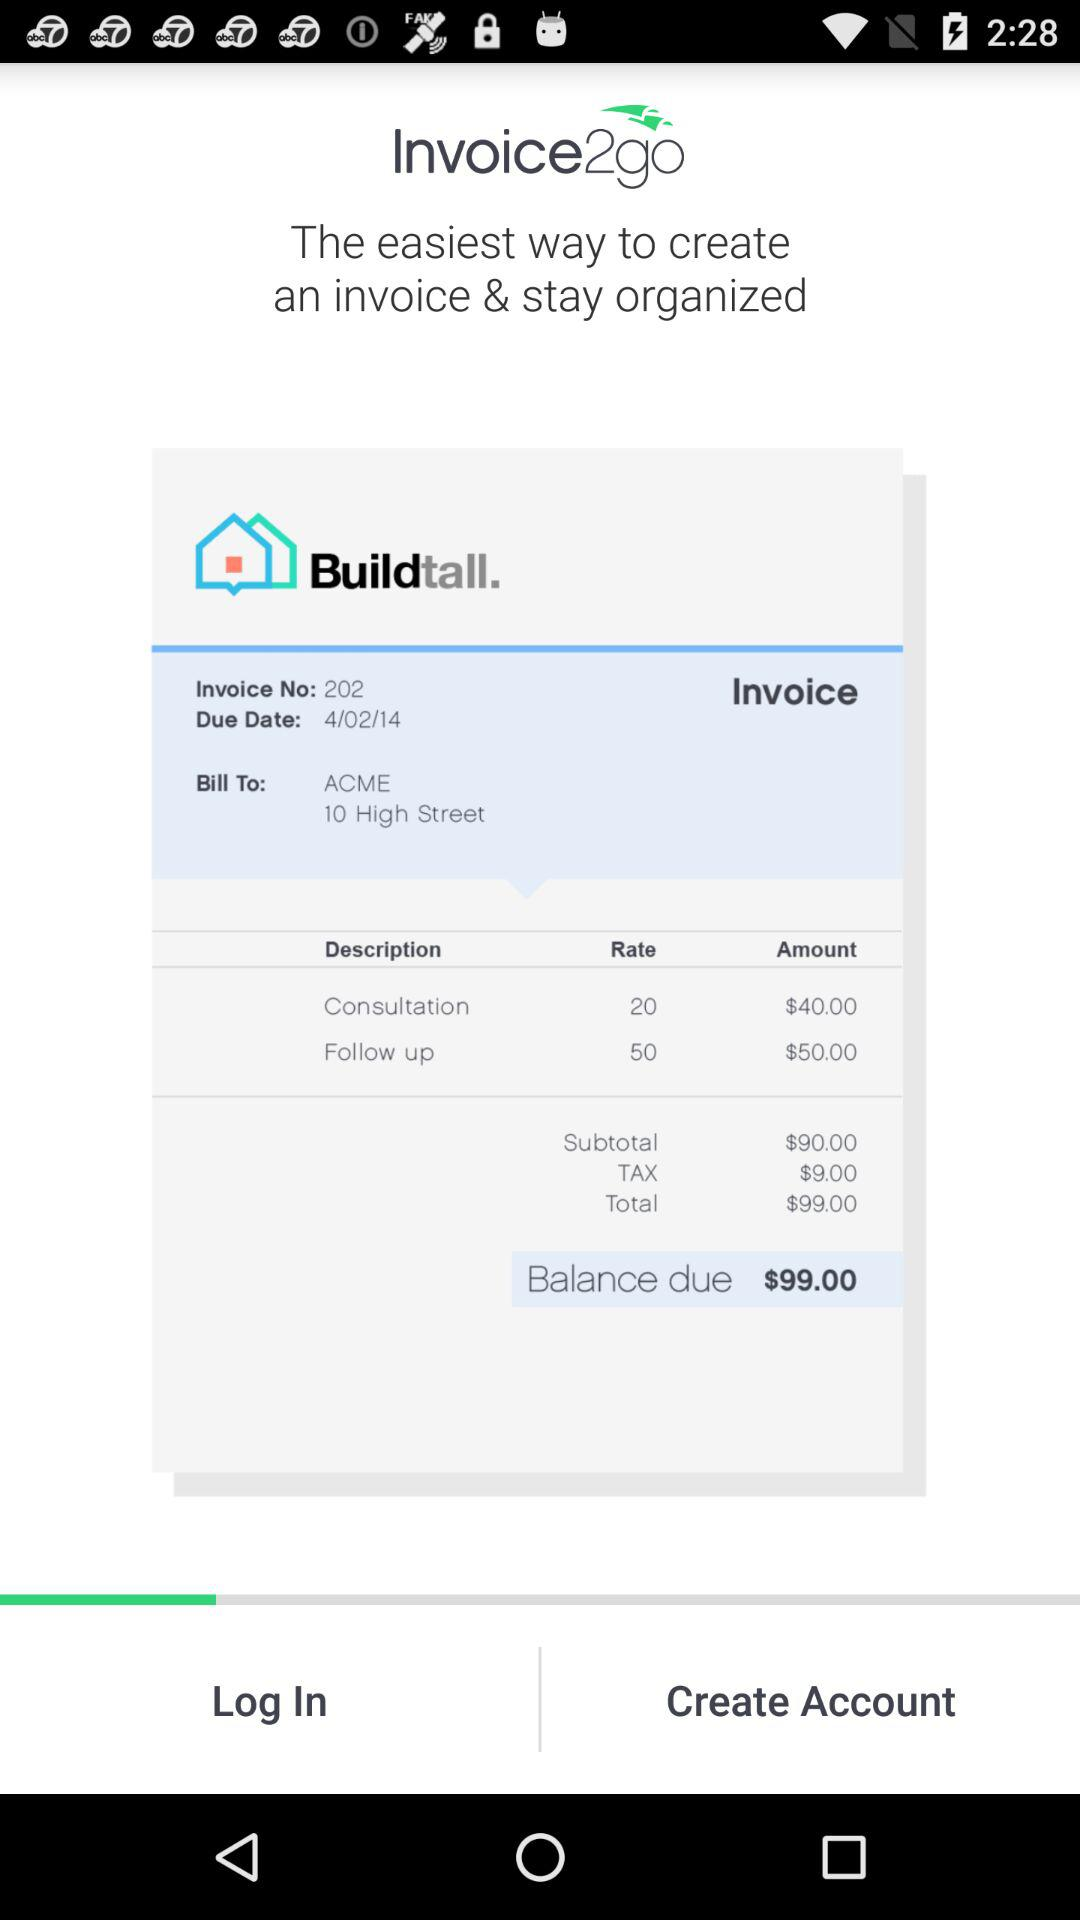What is the follow up rate? The follow up rate is 50. 